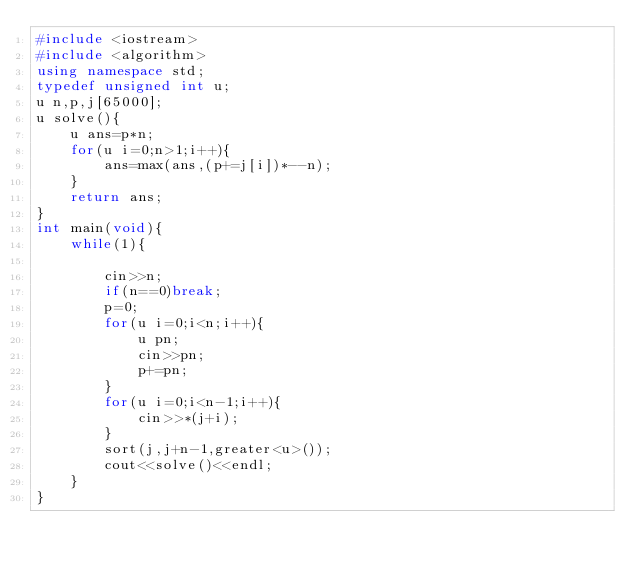<code> <loc_0><loc_0><loc_500><loc_500><_C++_>#include <iostream>
#include <algorithm>
using namespace std;
typedef unsigned int u;
u n,p,j[65000];
u solve(){
    u ans=p*n;
    for(u i=0;n>1;i++){
        ans=max(ans,(p+=j[i])*--n);
    }
    return ans;
}
int main(void){
    while(1){
        
        cin>>n;
        if(n==0)break;
        p=0;
        for(u i=0;i<n;i++){
            u pn;
            cin>>pn;
            p+=pn;
        }
        for(u i=0;i<n-1;i++){
            cin>>*(j+i);
        }
        sort(j,j+n-1,greater<u>());
        cout<<solve()<<endl;
    }
}</code> 